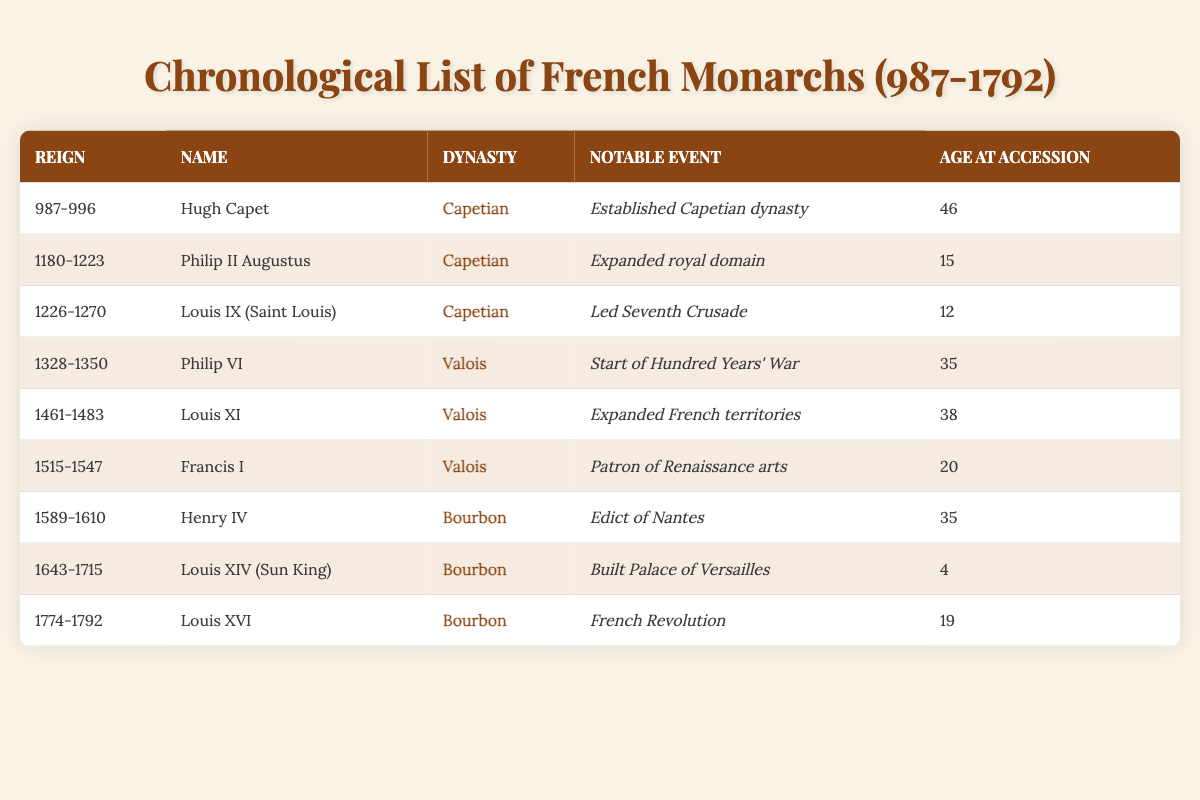What years did Louis XIV reign? Louis XIV reigned from 1643 to 1715, as indicated in the "Reign" column of the table.
Answer: 1643-1715 Who was the youngest monarch at accession? By checking the "Age at Accession" column, Louis XIV was 4 years old when he acceded to the throne, which is the lowest age listed.
Answer: Louis XIV What notable event is associated with Henry IV? The table shows that Henry IV's notable event was the Edict of Nantes, found in the corresponding row for his reign from 1589 to 1610.
Answer: Edict of Nantes Which dynasty had the longest reign according to the table? The Bourbon dynasty contained multiple monarchs, but the longest individual reign was Louis XIV's, from 1643 to 1715, totaling 72 years.
Answer: Bourbon How many monarchs were from the Valois dynasty? The data reveals three monarchs from the Valois dynasty: Philip VI, Louis XI, and Francis I. Counted, this gives us a total of three monarchs.
Answer: 3 What is the average age of accession for the Capetian dynasty? The Capetian dynasty has three monarchs: Hugh Capet (46), Philip II Augustus (15), and Louis IX (12). Calculating the average: (46 + 15 + 12) / 3 gives 73 / 3 = 24.33.
Answer: 24.33 Did any of the French monarchs reign for less than 20 years? By examining the "Reign" column, I can see that Louis IX reigned from 1226 to 1270 and others also have longer reigns; however, all monarchs listed in the table had reigns that span at least 22 years.
Answer: No Which monarch had the notable event of leading the Seventh Crusade? Referring to the "Notable Event" column, Louis IX is indicated as leading the Seventh Crusade, and his reign was from 1226 to 1270.
Answer: Louis IX Which monarch’s reign marked the start of the Hundred Years' War? The table specifies that Philip VI, who reigned from 1328 to 1350, marked the start of the Hundred Years' War.
Answer: Philip VI Is there a monarch from the Bourbon dynasty who had an accession age of 19? Looking at the "Age at Accession" column, Louis XVI is shown to have an accession age of 19, and he belonged to the Bourbon dynasty.
Answer: Yes 